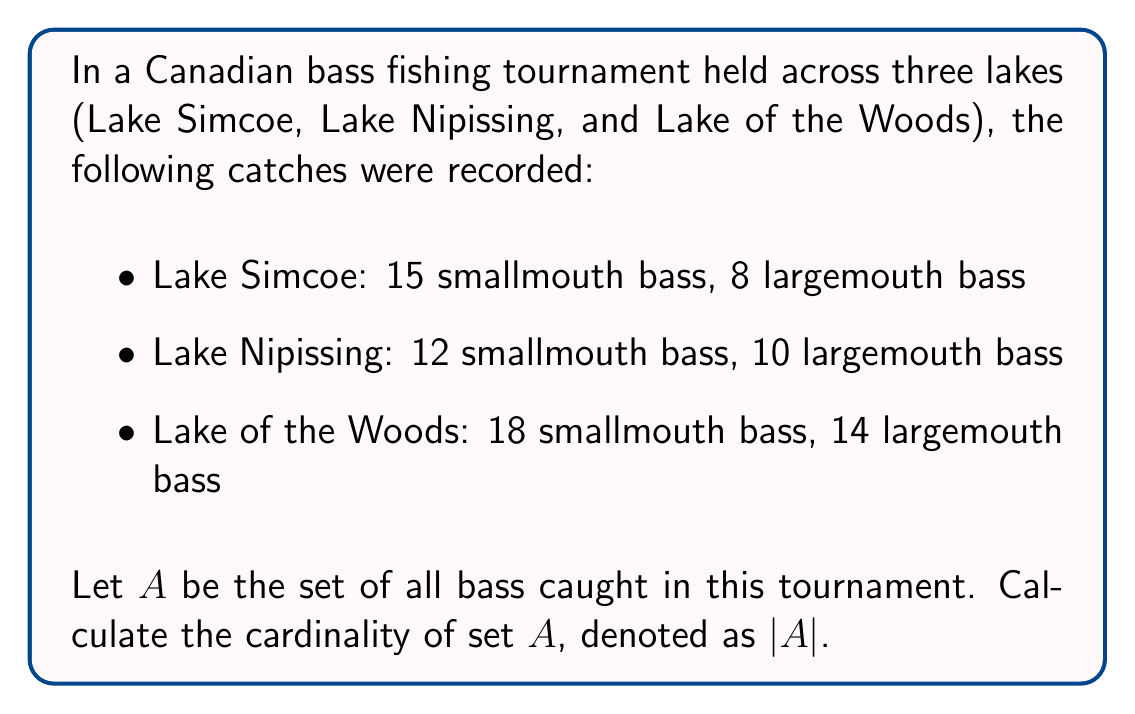Solve this math problem. To solve this problem, we need to follow these steps:

1) First, let's identify the elements of set $A$. Set $A$ contains all bass caught in the tournament, regardless of the species or the lake they were caught in.

2) We need to count the total number of bass caught in each lake:

   Lake Simcoe: $15 + 8 = 23$ bass
   Lake Nipissing: $12 + 10 = 22$ bass
   Lake of the Woods: $18 + 14 = 32$ bass

3) The cardinality of a set is the number of elements in the set. In this case, it's the total number of bass caught across all three lakes.

4) To find the total, we sum up the bass caught in each lake:

   $|A| = 23 + 22 + 32 = 77$

Therefore, the cardinality of set $A$ is 77.

Note: In set theory, we don't need to distinguish between different types of bass or the lakes they were caught in for this calculation. We're simply counting the total number of elements (bass) in the set.
Answer: $|A| = 77$ 